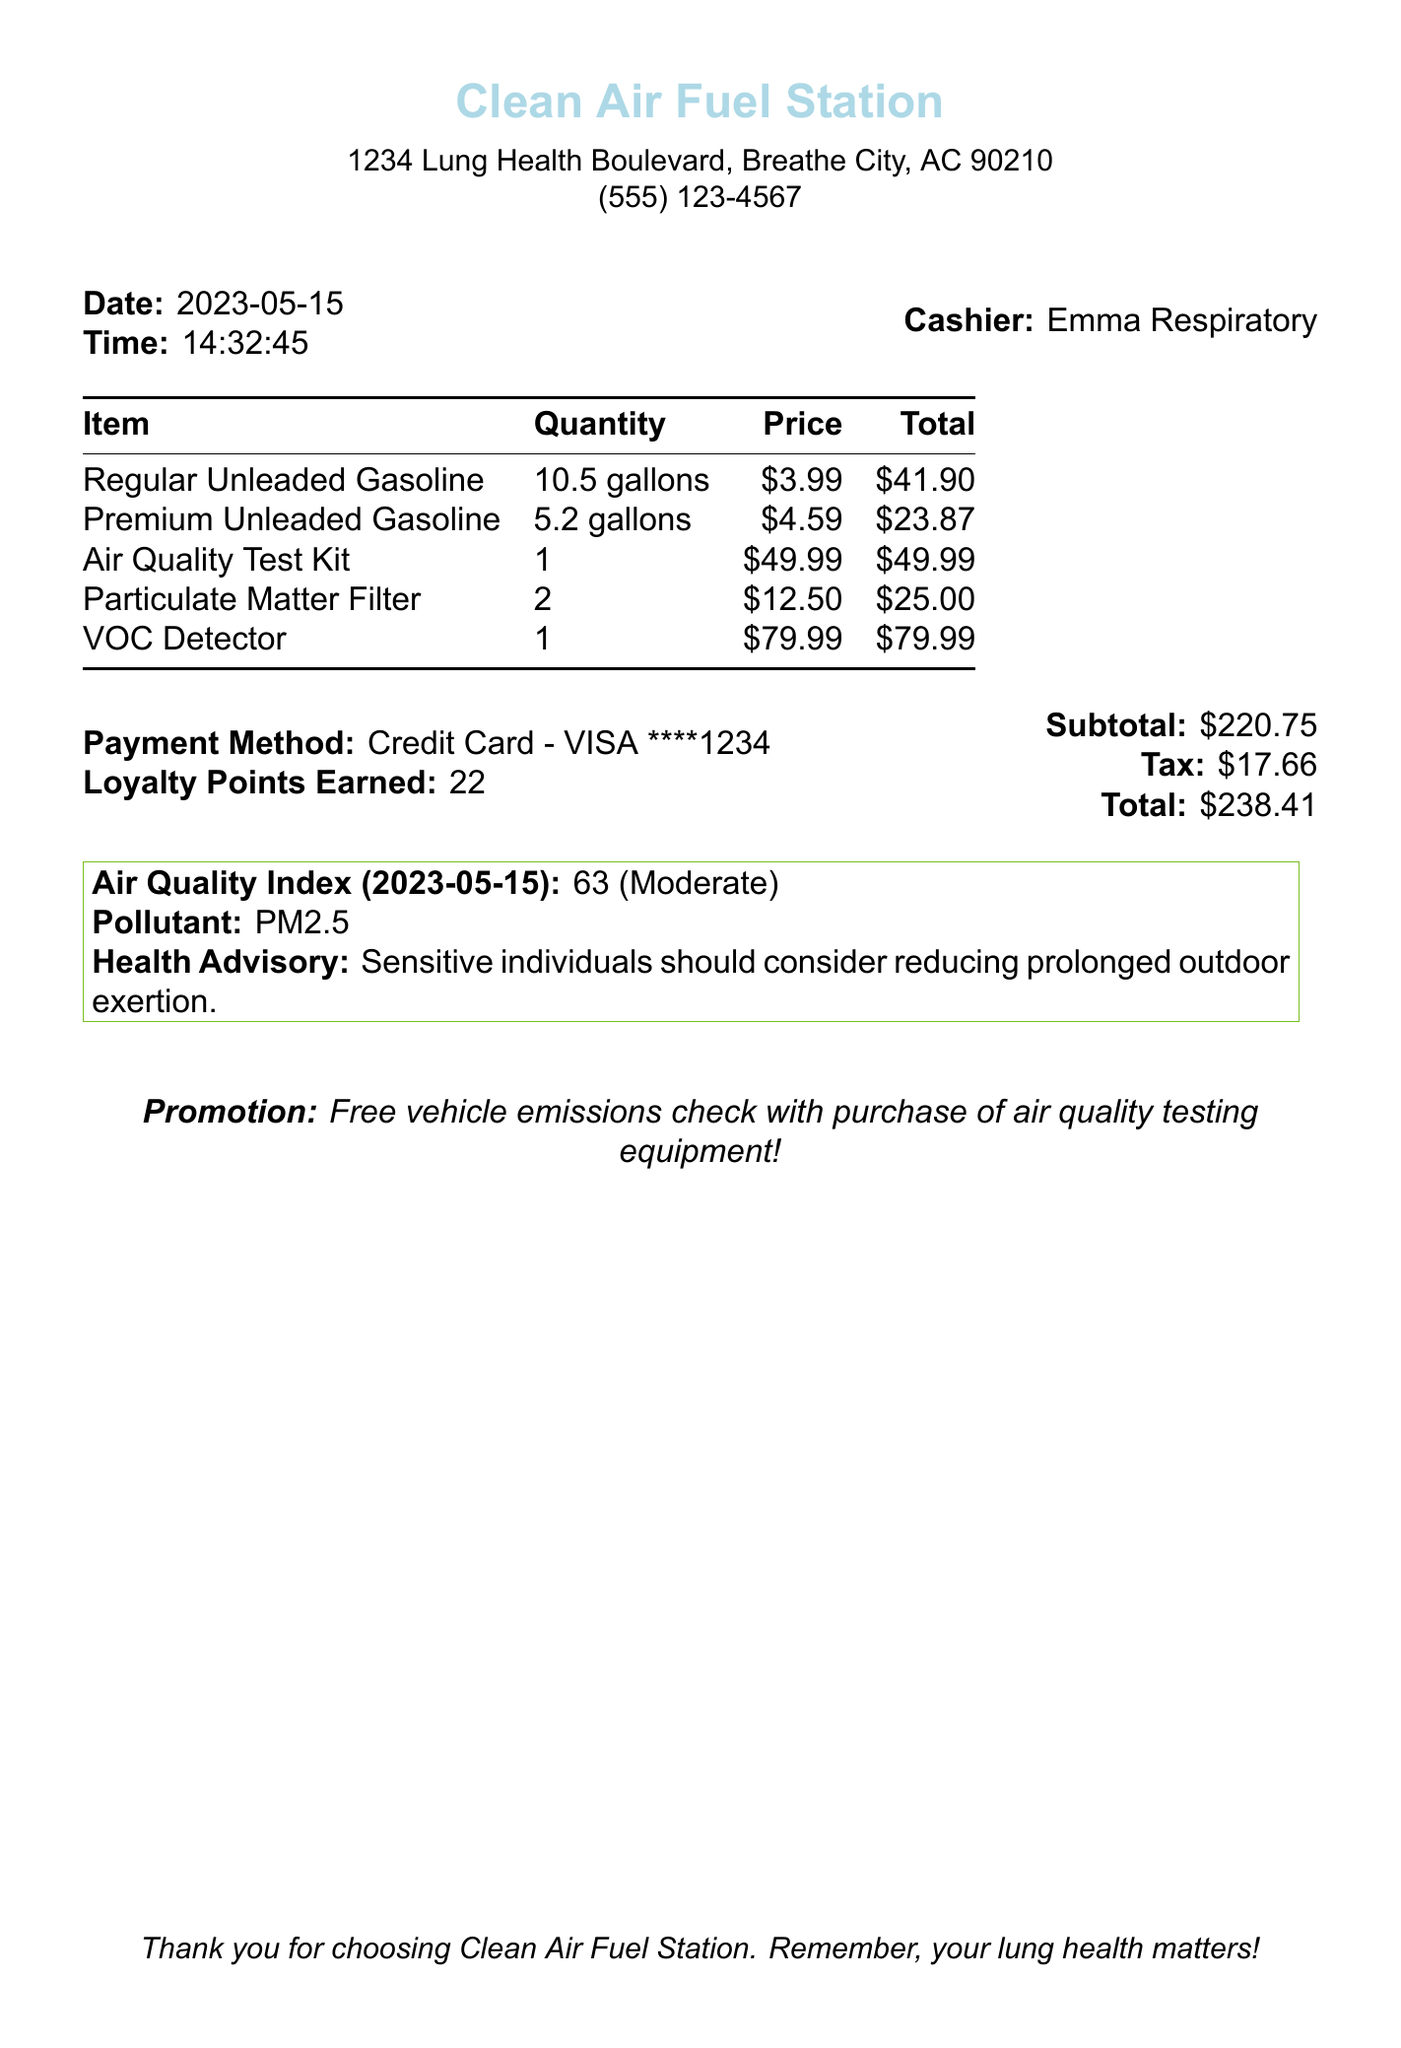What is the store name? The store name is clearly stated at the top of the receipt.
Answer: Clean Air Fuel Station What is the date of the transaction? The date is specified in the document's header section.
Answer: 2023-05-15 Who was the cashier? The cashier's name is listed in the receipt.
Answer: Emma Respiratory How many gallons of Regular Unleaded Gasoline were purchased? The quantity of Regular Unleaded Gasoline is detailed in the items section.
Answer: 10.5 gallons What is the total amount spent? The total amount is provided at the end of the receipt near the payment details.
Answer: $238.41 What is the health advisory for air quality? The health advisory is noted in the air quality index section of the receipt.
Answer: Sensitive individuals should consider reducing prolonged outdoor exertion What promotion is offered with the purchase of air quality testing equipment? The promotion is mentioned explicitly on the receipt.
Answer: Free vehicle emissions check with purchase of air quality testing equipment! What is the quantity of VOC Detectors purchased? The quantity of VOC Detectors is included in the items list.
Answer: 1 What is the air quality index reading on the date? The air quality index reading is provided in the document under air quality index.
Answer: 63 (Moderate) How much tax was charged? The tax amount is stated in the financial section of the receipt.
Answer: $17.66 